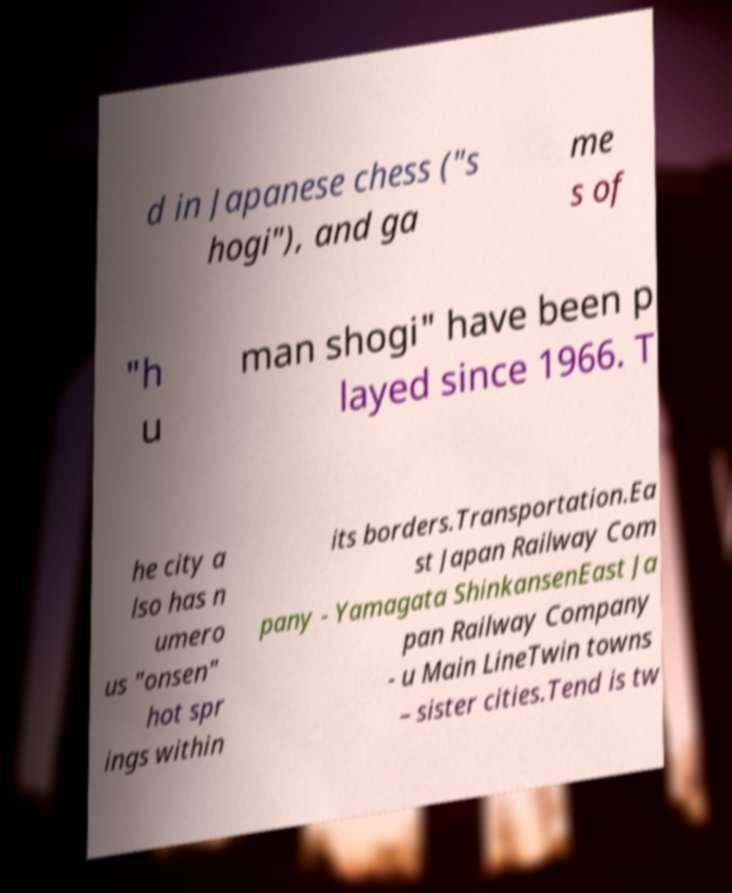There's text embedded in this image that I need extracted. Can you transcribe it verbatim? d in Japanese chess ("s hogi"), and ga me s of "h u man shogi" have been p layed since 1966. T he city a lso has n umero us "onsen" hot spr ings within its borders.Transportation.Ea st Japan Railway Com pany - Yamagata ShinkansenEast Ja pan Railway Company - u Main LineTwin towns – sister cities.Tend is tw 